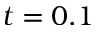Convert formula to latex. <formula><loc_0><loc_0><loc_500><loc_500>t = 0 . 1</formula> 